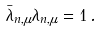<formula> <loc_0><loc_0><loc_500><loc_500>\bar { \lambda } _ { n , \mu } \lambda _ { n , \mu } = 1 \, .</formula> 